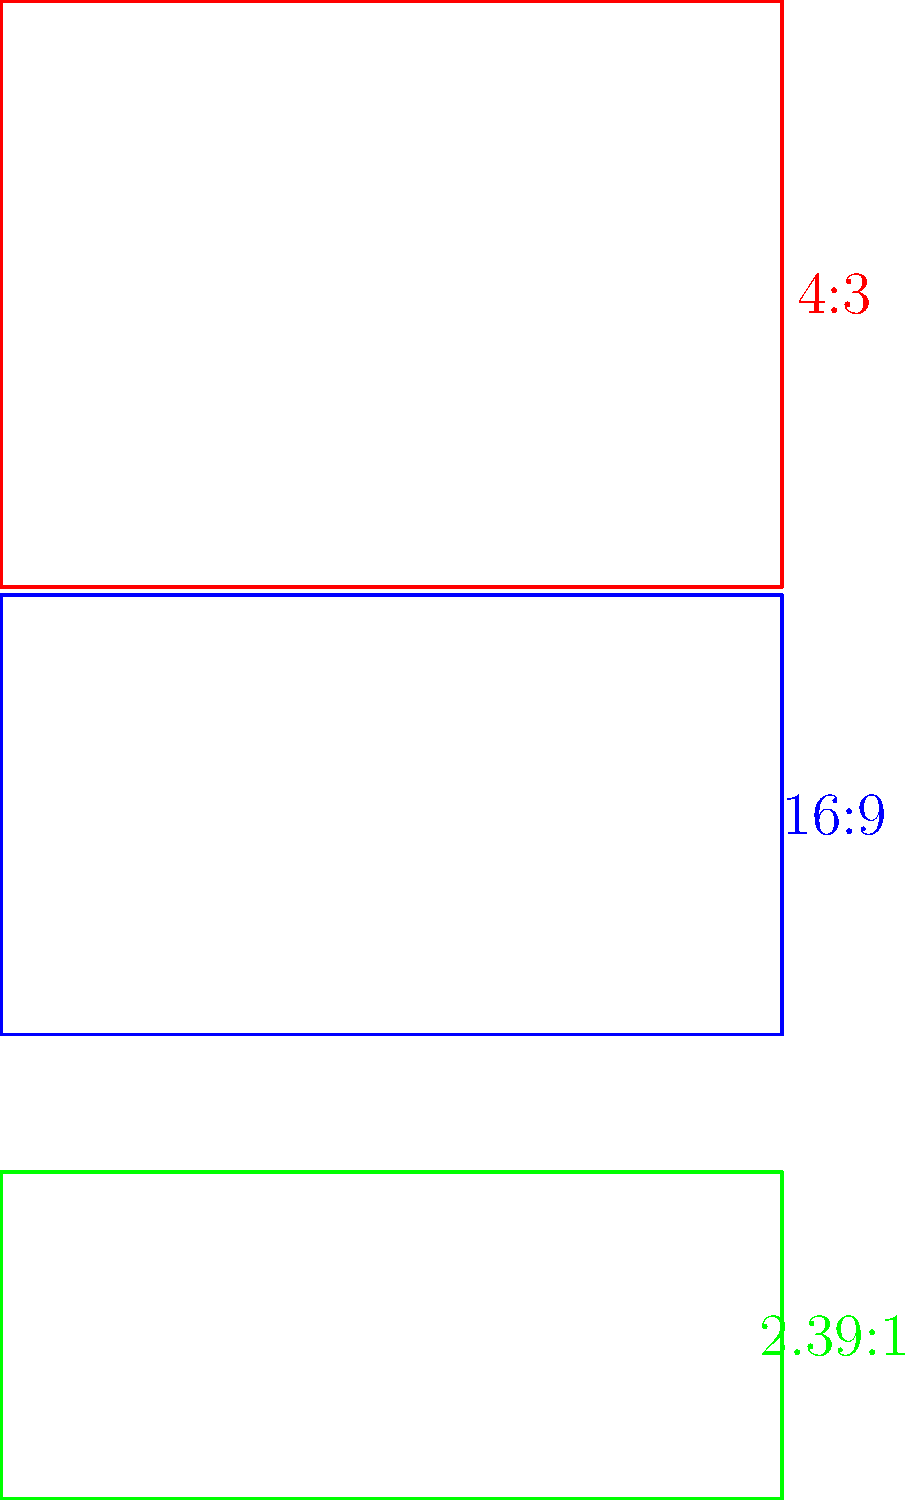In the diagram above, three common aspect ratios used in filmmaking are represented. Which aspect ratio would be most suitable for capturing a vast, panoramic landscape scene in a modern epic film, and why? To answer this question, let's analyze each aspect ratio and its characteristics:

1. 4:3 (red rectangle):
   - This is the classic "Academy ratio" used in early films and older television.
   - It has a nearly square shape, which limits horizontal composition.
   - Not ideal for panoramic landscapes due to its narrow width.

2. 16:9 (blue rectangle):
   - This is the standard widescreen format used in modern television and many films.
   - It offers a good balance between width and height.
   - Better than 4:3 for landscapes, but still not the widest option.

3. 2.39:1 (green rectangle):
   - This is the widest aspect ratio shown, also known as CinemaScope or anamorphic widescreen.
   - It provides the most horizontal space for composition.
   - Ideal for capturing vast landscapes and creating a sense of epic scale.

For a vast, panoramic landscape scene in a modern epic film, the 2.39:1 aspect ratio would be most suitable because:

1. It offers the widest field of view, allowing for the inclusion of more horizontal elements in the frame.
2. The extreme width creates a sense of grandeur and epic scale, which is perfect for landscape shots.
3. It mimics the natural way humans perceive wide vistas, as our eyes scan horizontally across a scene.
4. This aspect ratio is commonly used in big-budget epic films to create a more immersive cinematic experience.
5. It allows for creative composition techniques, such as using negative space or the rule of thirds, to emphasize the vastness of the landscape.

Therefore, the 2.39:1 aspect ratio (represented by the green rectangle) would be the most effective choice for capturing a vast, panoramic landscape scene in a modern epic film.
Answer: 2.39:1 (CinemaScope) 